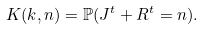<formula> <loc_0><loc_0><loc_500><loc_500>K ( k , n ) = \mathbb { P } ( J ^ { t } + R ^ { t } = n ) .</formula> 